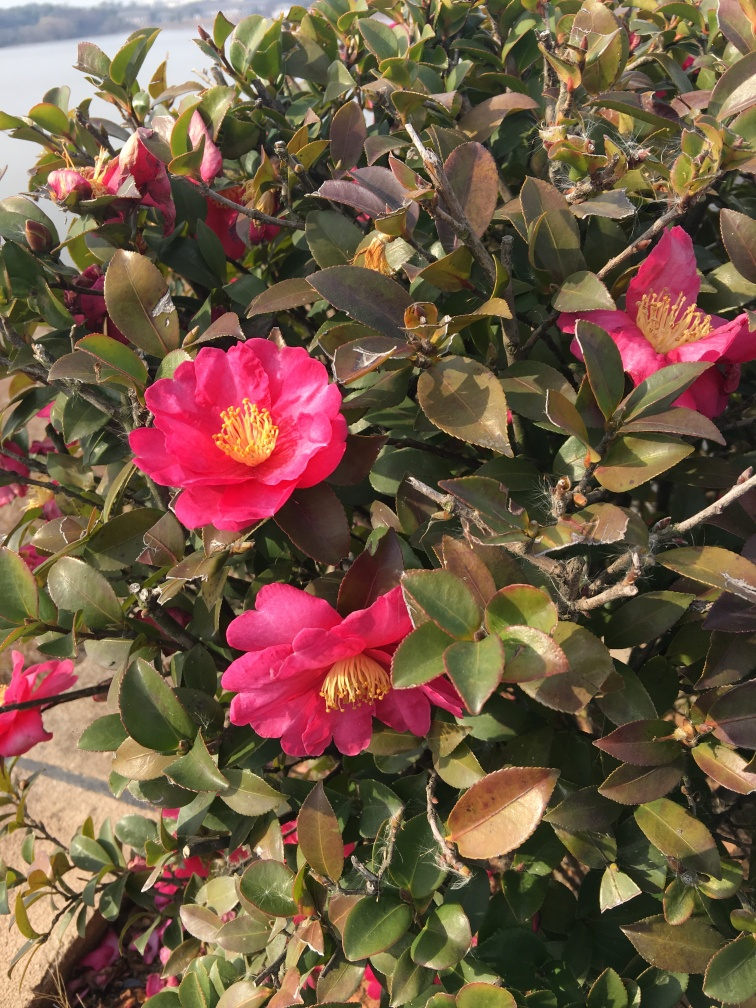Could you tell me more about where this plant species can be typically found? Certainly! Camellia plants, including the beautiful specimens shown in the image, are native to eastern and southern Asia. They typically flourish in woodland areas and gardens where the climate is temperate and the soil is well-drained and slightly acidic. 